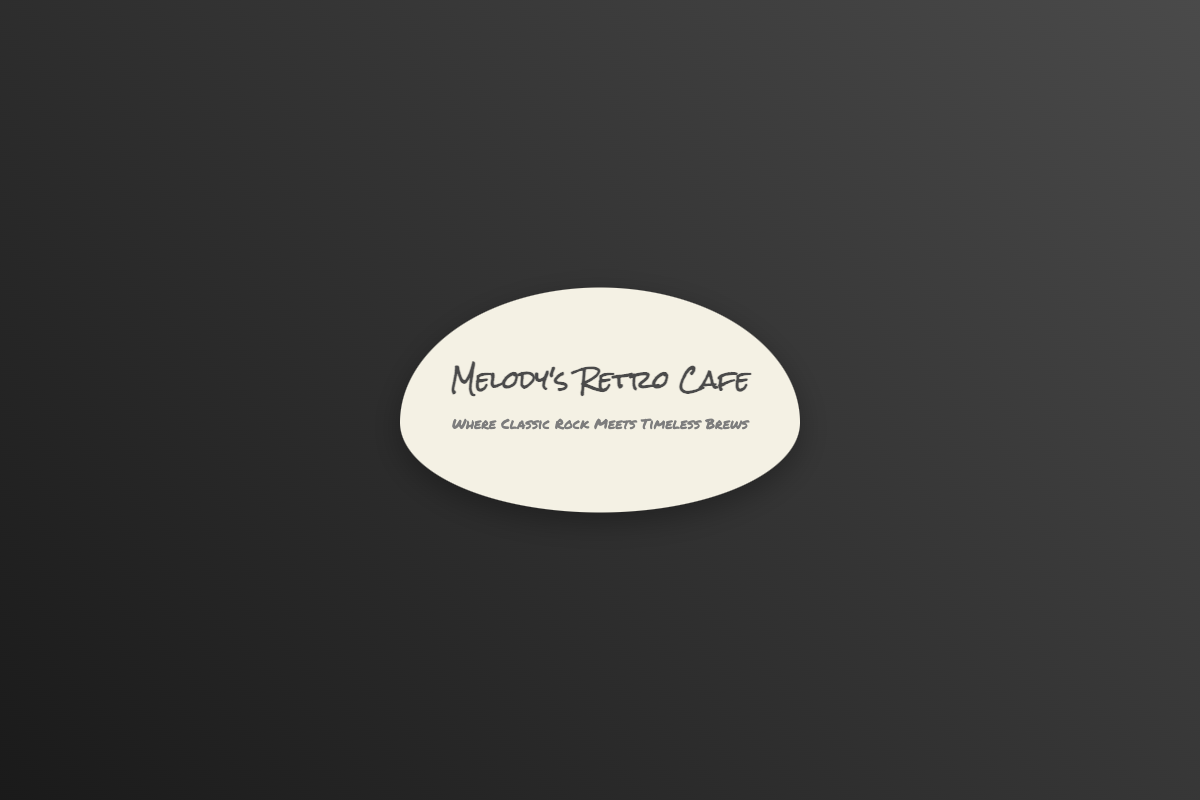What is the cafe's name? The name of the cafe is prominently displayed at the top of the card.
Answer: Melody's Retro Cafe What is the tagline of the cafe? The tagline conveys the cafe's theme and is located beneath the name.
Answer: Where Classic Rock Meets Timeless Brews What is the contact phone number? The contact phone number is listed in the contact section on the back of the card.
Answer: +1 (555) 123-4567 What is the email address provided? The email address is also in the contact section and allows customers to reach out for inquiries.
Answer: info@melodysretrocafe.com How many social media links are listed? The number of social media links is a count of the links provided in the social media section.
Answer: 4 Which social media platform is represented by "FB"? The abbreviation "FB" refers to the social media platform mentioned on the back.
Answer: Facebook What is the location address of the cafe? The cafe's address is provided in the contact information section.
Answer: 456 Vinyl Road, Groovetown, CA 90210, USA What shape is the business card? The business card's design is mentioned in the context and shape description.
Answer: Guitar pick shape What is the predominant color scheme of the front of the card? The colors on the front are representative of the cafe's retro theme.
Answer: Light beige and dark gray What type of icons are used on the front? The icons represent different elements associated with the theme of the cafe.
Answer: Guitar, vinyl record, musical notes, coffee cup 